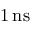<formula> <loc_0><loc_0><loc_500><loc_500>1 \, n s</formula> 